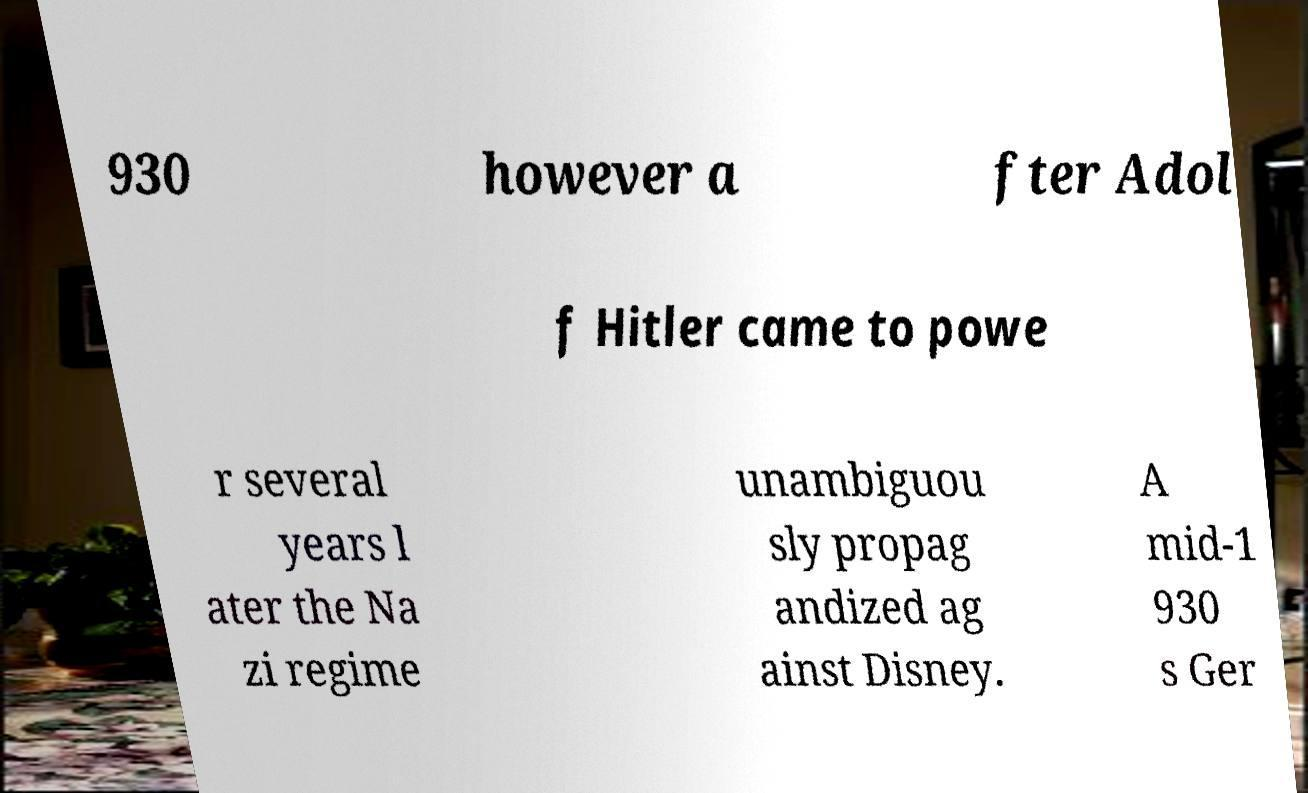Could you assist in decoding the text presented in this image and type it out clearly? 930 however a fter Adol f Hitler came to powe r several years l ater the Na zi regime unambiguou sly propag andized ag ainst Disney. A mid-1 930 s Ger 